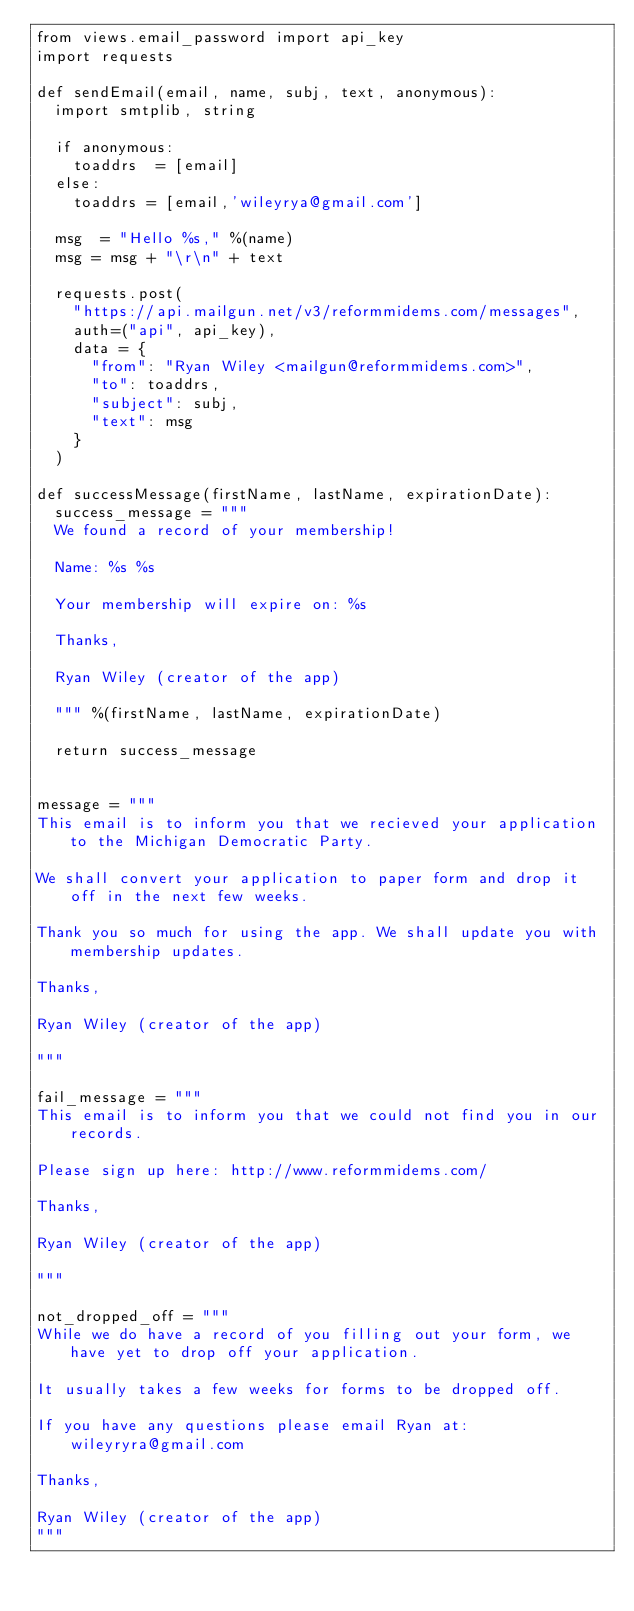Convert code to text. <code><loc_0><loc_0><loc_500><loc_500><_Python_>from views.email_password import api_key
import requests

def sendEmail(email, name, subj, text, anonymous):
	import smtplib, string

	if anonymous:
		toaddrs  = [email]
	else:
		toaddrs = [email,'wileyrya@gmail.com']

	msg  = "Hello %s," %(name)
	msg = msg + "\r\n" + text

	requests.post(
		"https://api.mailgun.net/v3/reformmidems.com/messages",
		auth=("api", api_key),
		data = {
			"from": "Ryan Wiley <mailgun@reformmidems.com>",
			"to": toaddrs,
			"subject": subj,
			"text": msg
		}
	)

def successMessage(firstName, lastName, expirationDate):
	success_message = """
	We found a record of your membership!

	Name: %s %s

	Your membership will expire on: %s

	Thanks,

	Ryan Wiley (creator of the app)

	""" %(firstName, lastName, expirationDate)

	return success_message


message = """
This email is to inform you that we recieved your application to the Michigan Democratic Party.

We shall convert your application to paper form and drop it off in the next few weeks.

Thank you so much for using the app. We shall update you with membership updates.

Thanks,

Ryan Wiley (creator of the app)

"""

fail_message = """
This email is to inform you that we could not find you in our records.

Please sign up here: http://www.reformmidems.com/

Thanks,

Ryan Wiley (creator of the app)

"""

not_dropped_off = """
While we do have a record of you filling out your form, we have yet to drop off your application.

It usually takes a few weeks for forms to be dropped off.

If you have any questions please email Ryan at: wileyryra@gmail.com

Thanks,

Ryan Wiley (creator of the app)
"""
</code> 